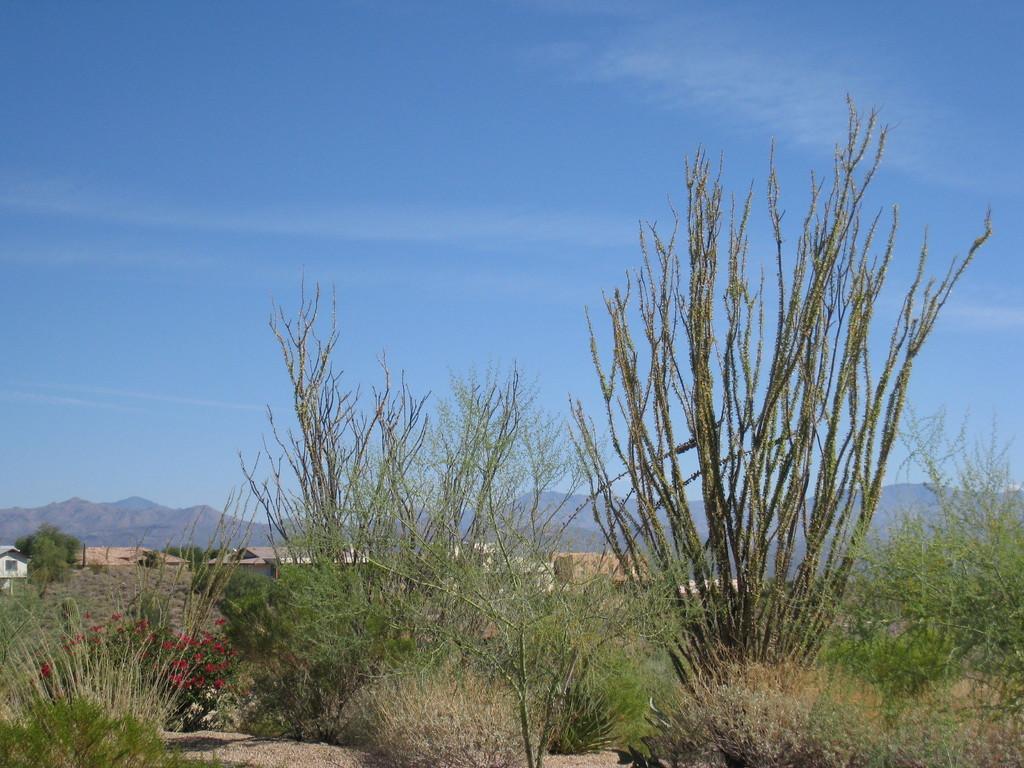Could you give a brief overview of what you see in this image? In this image there are plants and grass on the ground. To the left there are flowers to a plant. In the background there are houses, mountains and trees. At the top there is the sky. 